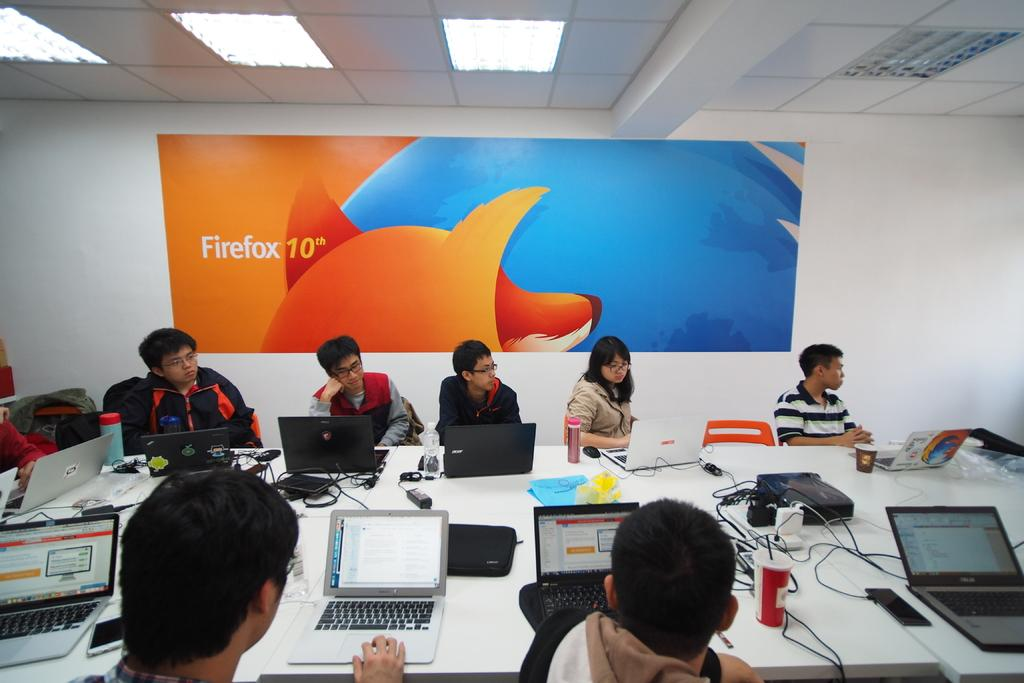Provide a one-sentence caption for the provided image. A painting that says firefox 10th it's orange and blue. 